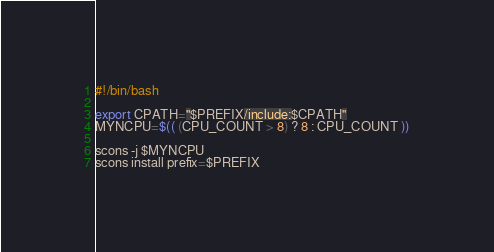<code> <loc_0><loc_0><loc_500><loc_500><_Bash_>#!/bin/bash

export CPATH="$PREFIX/include:$CPATH"
MYNCPU=$(( (CPU_COUNT > 8) ? 8 : CPU_COUNT ))

scons -j $MYNCPU
scons install prefix=$PREFIX</code> 